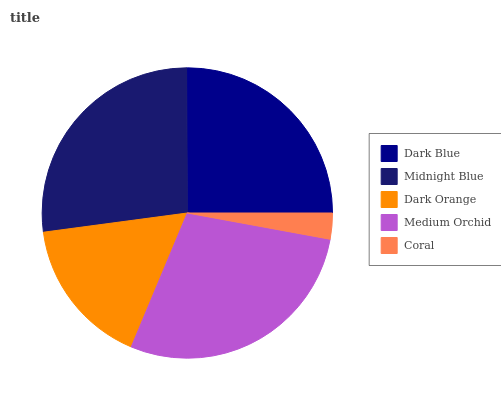Is Coral the minimum?
Answer yes or no. Yes. Is Medium Orchid the maximum?
Answer yes or no. Yes. Is Midnight Blue the minimum?
Answer yes or no. No. Is Midnight Blue the maximum?
Answer yes or no. No. Is Midnight Blue greater than Dark Blue?
Answer yes or no. Yes. Is Dark Blue less than Midnight Blue?
Answer yes or no. Yes. Is Dark Blue greater than Midnight Blue?
Answer yes or no. No. Is Midnight Blue less than Dark Blue?
Answer yes or no. No. Is Dark Blue the high median?
Answer yes or no. Yes. Is Dark Blue the low median?
Answer yes or no. Yes. Is Medium Orchid the high median?
Answer yes or no. No. Is Dark Orange the low median?
Answer yes or no. No. 